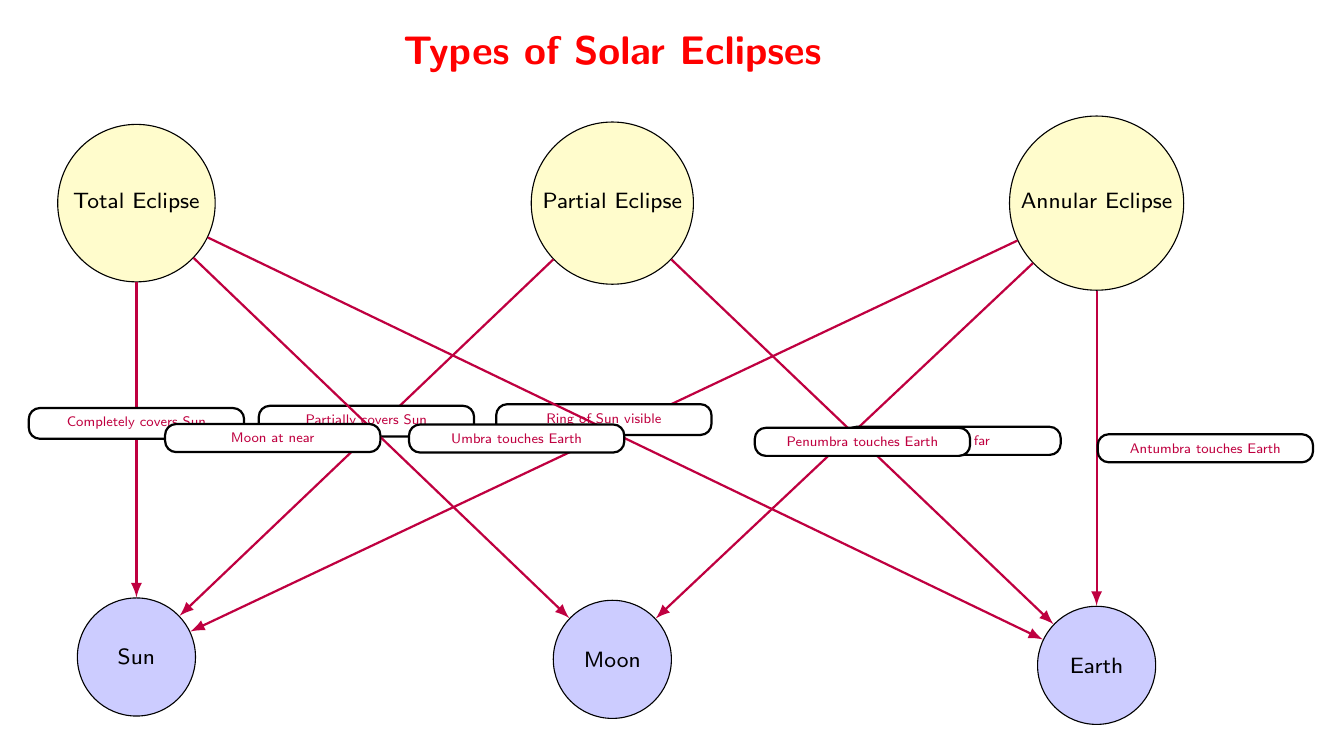What are the three types of solar eclipses illustrated in the diagram? The diagram labels three types of solar eclipses as Total Eclipse, Partial Eclipse, and Annular Eclipse.
Answer: Total Eclipse, Partial Eclipse, Annular Eclipse What does a Total Eclipse do to the Sun? According to the diagram, a Total Eclipse completely covers the Sun.
Answer: Completely covers Sun Which celestial body is at the center of the Partial Eclipse description? The diagram shows that the Moon is positioned below the Partial Eclipse label, indicating it is at the center of the description for Partial Eclipse.
Answer: Moon What type of eclipse occurs when the Moon is at a distance? The diagram specifies that when the Moon is at a far distance, an Annular Eclipse occurs.
Answer: Annular Eclipse What part of Earth is affected during a Total Eclipse? The diagram states that during a Total Eclipse, the Umbra touches Earth, indicating the area affected.
Answer: Umbra touches Earth What touches the Earth during a Partial Eclipse? The diagram indicates that during a Partial Eclipse, the Penumbra touches the Earth.
Answer: Penumbra touches Earth In the diagram, which type of eclipse is represented by just a ring of the Sun being visible? The diagram clearly states that the Annular Eclipse is characterized by a ring of the Sun being visible.
Answer: Annular Eclipse How many arrows are used to connect the types of eclipses to their descriptions? The diagram uses six arrows to connect the types of eclipses to their descriptions, linking them to relevant details about how they interact with the Sun, Moon, and Earth.
Answer: Six arrows What visual element distinguishes the Total Eclipse in the diagram? The Total Eclipse is specifically noted for its description that states it completely covers the Sun, distinguishing it visually from other types.
Answer: Completely covers Sun 